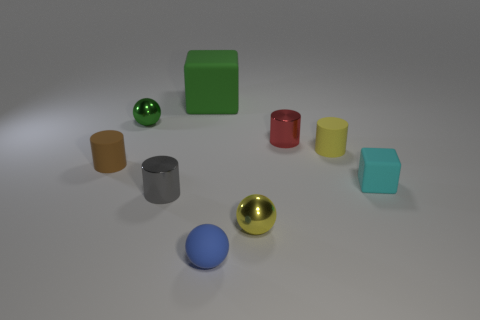Subtract all red metal cylinders. How many cylinders are left? 3 Subtract all brown cylinders. How many cylinders are left? 3 Add 1 big green shiny cubes. How many big green shiny cubes exist? 1 Subtract 1 yellow spheres. How many objects are left? 8 Subtract all blocks. How many objects are left? 7 Subtract 1 cubes. How many cubes are left? 1 Subtract all purple cylinders. Subtract all blue spheres. How many cylinders are left? 4 Subtract all brown cubes. How many yellow balls are left? 1 Subtract all gray metal cubes. Subtract all shiny objects. How many objects are left? 5 Add 6 rubber blocks. How many rubber blocks are left? 8 